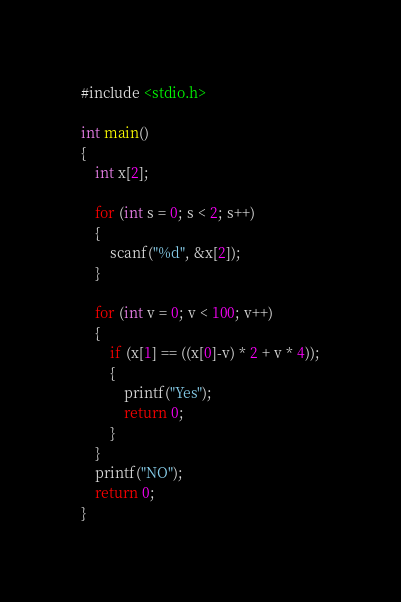<code> <loc_0><loc_0><loc_500><loc_500><_C_>#include <stdio.h>

int main()
{
    int x[2];

    for (int s = 0; s < 2; s++)
    {
        scanf("%d", &x[2]);
    }

    for (int v = 0; v < 100; v++)
    {
        if (x[1] == ((x[0]-v) * 2 + v * 4));
        {
            printf("Yes");
            return 0;
        }
    }
    printf("NO");
    return 0;
}</code> 